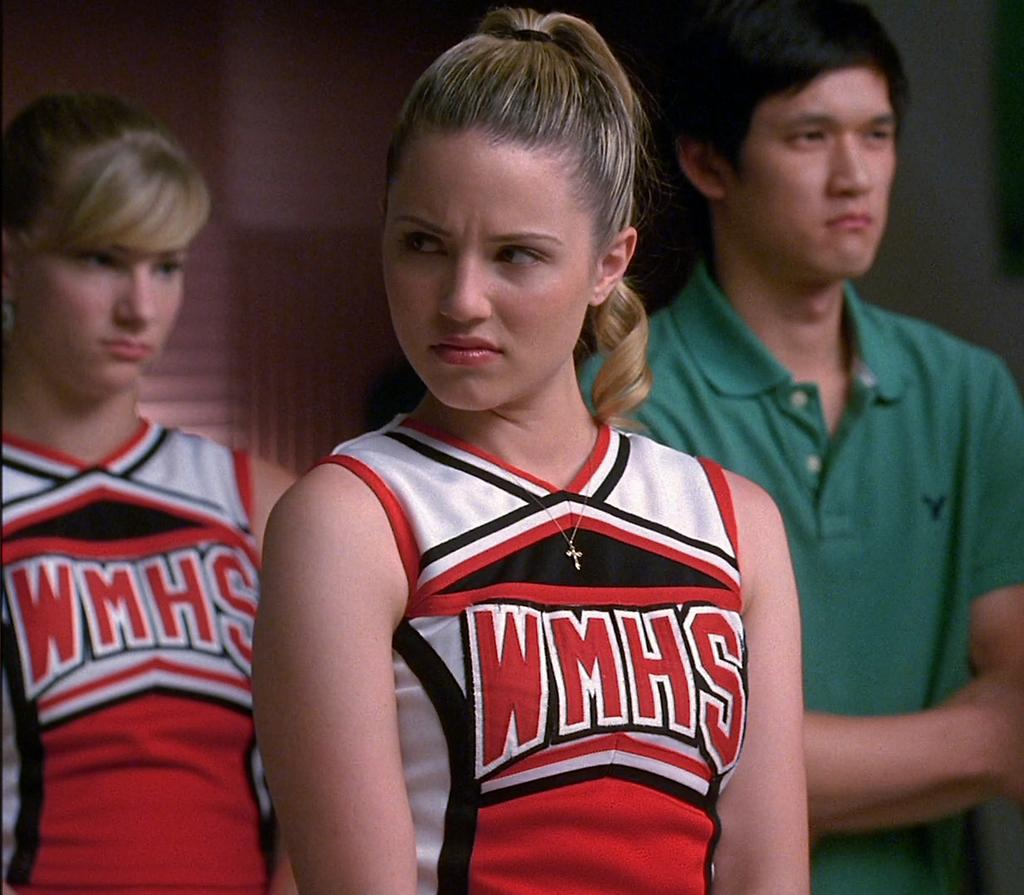<image>
Present a compact description of the photo's key features. A young woman wearing a shirt which reads WMHS 